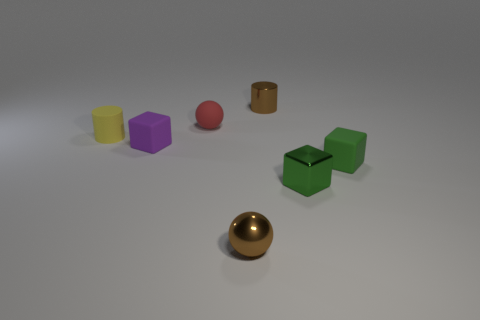How might the placement of these objects suggest relationships or interactions among them? The spatial arrangement of the objects on the surface might suggest intentional grouping or categorization. For instance, the small brown cylinder and golden sphere being closer to each other could indicate a pairing, perhaps based on their cylindrical shapes, despite their different sizes and colors.  Imagine these objects are part of a storytelling scene. What story could they be telling? One could envision a story where the objects represent characters in a social gathering. The golden sphere might be the illustrious guest of honor, catching everyone's attention, while the green cubes could be twins having a quiet conversation aside. The red sphere might be a bright personality, perhaps cracking jokes near the more serious, purple authority figure. 